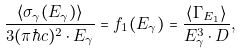<formula> <loc_0><loc_0><loc_500><loc_500>\frac { \left < \sigma _ { \gamma } ( E _ { \gamma } ) \right > } { 3 ( \pi \hbar { c } ) ^ { 2 } \cdot E _ { \gamma } } = f _ { 1 } ( E _ { \gamma } ) = \frac { \left < \Gamma _ { E _ { 1 } } \right > } { E _ { \gamma } ^ { 3 } \cdot D } ,</formula> 